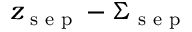Convert formula to latex. <formula><loc_0><loc_0><loc_500><loc_500>z _ { s e p } - \Sigma _ { s e p }</formula> 